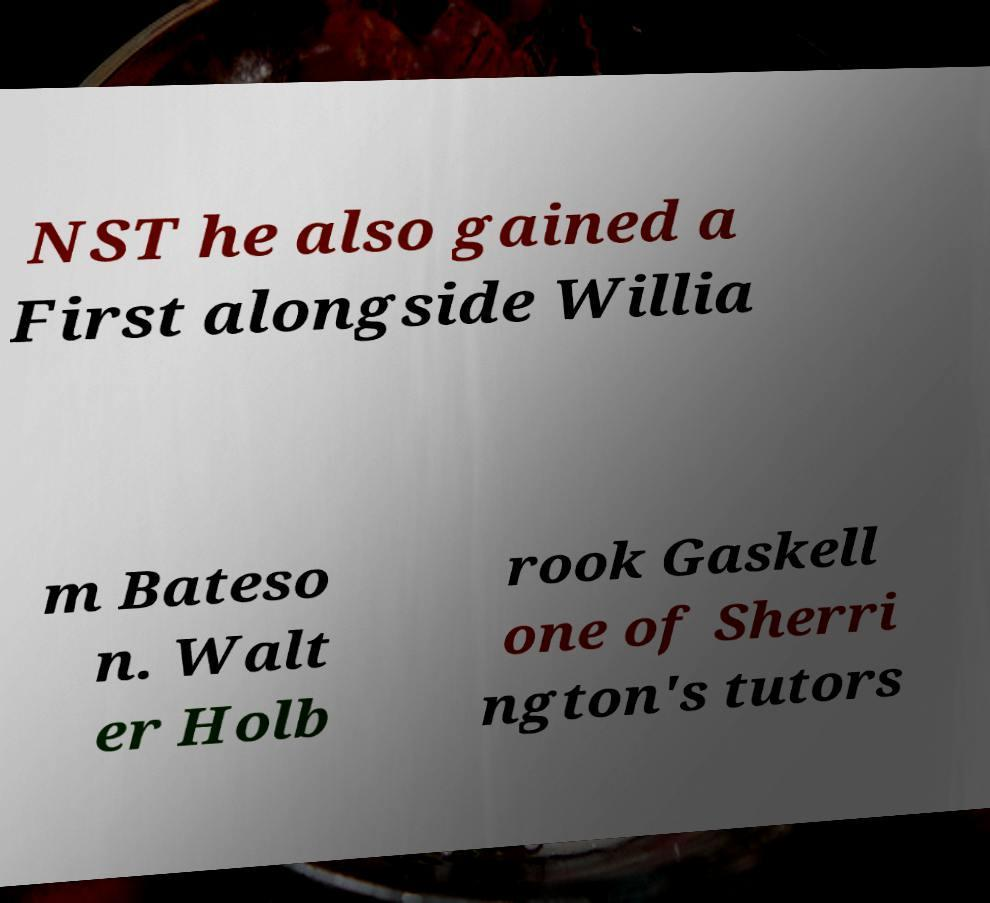There's text embedded in this image that I need extracted. Can you transcribe it verbatim? NST he also gained a First alongside Willia m Bateso n. Walt er Holb rook Gaskell one of Sherri ngton's tutors 